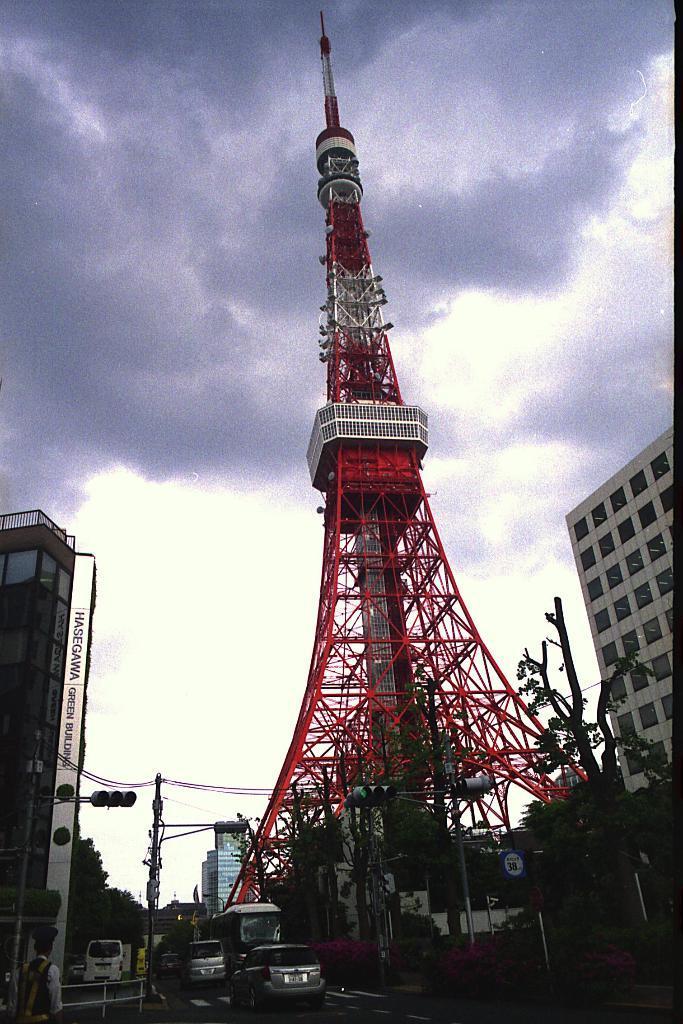Please provide a concise description of this image. In this image in front there are vehicles on the road. On the left side of the image there is a metal fence. There are traffic signals. In the center of the image there is a tower. There are trees, buildings. In the background of the image there is sky. 